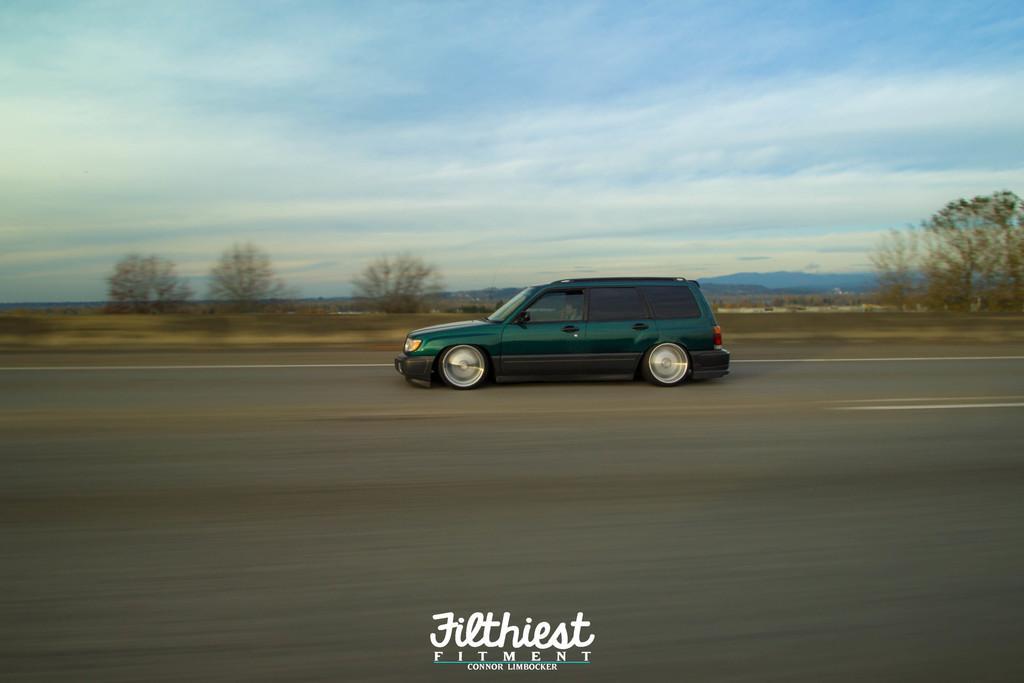Please provide a concise description of this image. In this image I can see the green color vehicle on the road. In the background I can see many trees, mountains, clouds and the sky. 